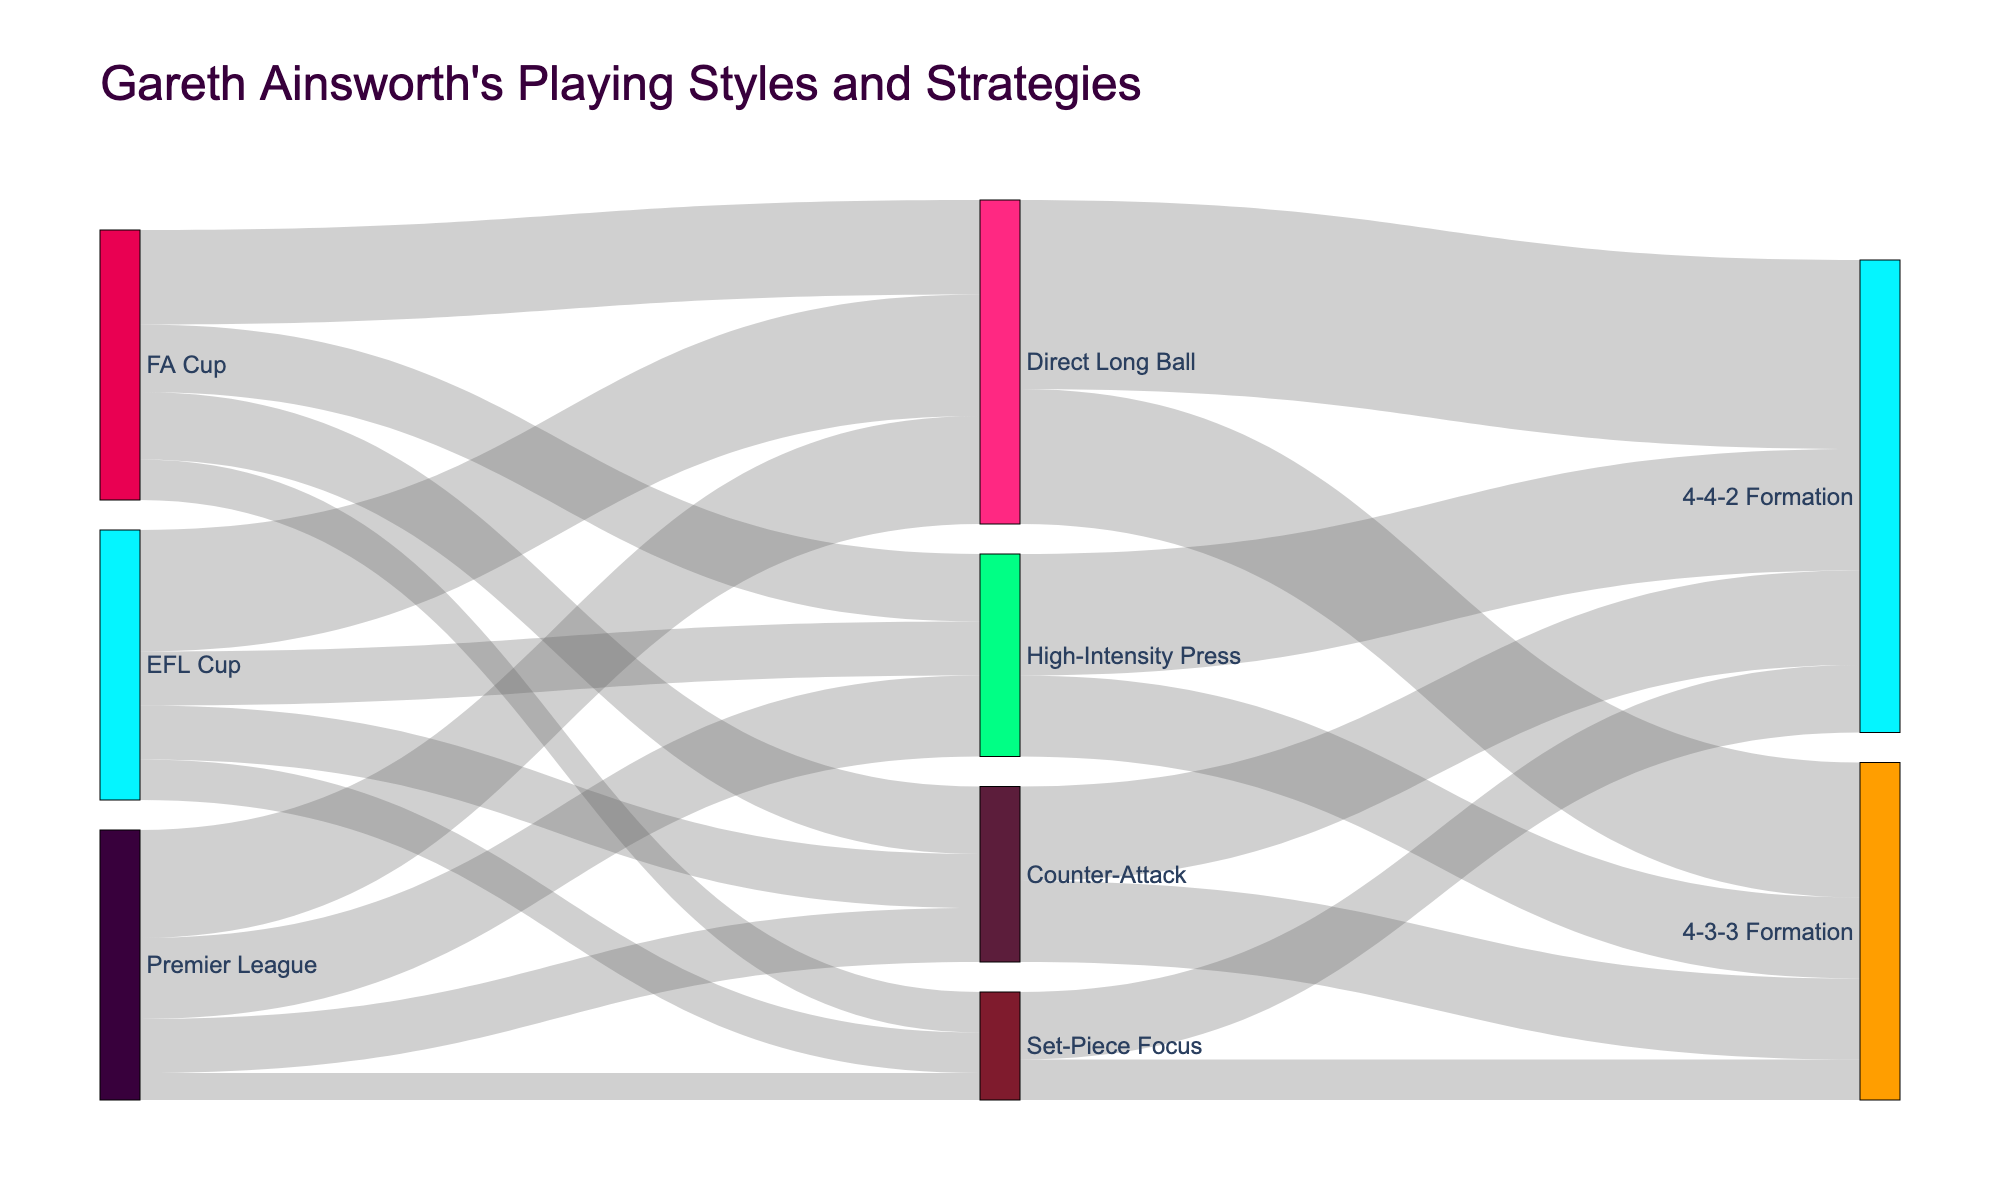what is the total value allocated to the High-Intensity Press strategy in all competitions? To find the total value for High-Intensity Press, sum the values for this strategy across Premier League, FA Cup, and EFL Cup. As given, Premier League: 30, FA Cup: 25, and EFL Cup: 20. Thus, 30 + 25 + 20 = 75
Answer: 75 Which competition employs the Direct Long Ball strategy the most? By comparing the values for Direct Long Ball across the different competitions, we see Premier League: 40, FA Cup: 35, and EFL Cup: 45. The EFL Cup has the highest value with 45
Answer: EFL Cup What formation is most frequently used with the Counter-Attack strategy? To determine the most frequently used formation, compare the values for formations linked to Counter-Attack. The values are 4-4-2: 35 and 4-3-3: 30. Thus, 4-4-2 Formation is used most frequently
Answer: 4-4-2 Formation How many playing styles are visualized in the diagram? The playing styles in the diagram are High-Intensity Press, Direct Long Ball, Counter-Attack, and Set-Piece Focus. Counting these, there are a total of 4
Answer: 4 What is the combined value of the Set-Piece Focus strategy across all competitions? Sum the values allocated to Set-Piece Focus in each competition: Premier League: 10, FA Cup: 15, and EFL Cup: 15. Thus, 10 + 15 + 15 = 40
Answer: 40 Between the Premier League and FA Cup, which competition uses the 4-3-3 formation in conjunction with High-Intensity Press more frequently? First, identify the values for 4-3-3 with High-Intensity Press in each competition. The data indicates that this specific link isn't broken down by competition within the diagram, implying direct totals aren't available; hence, unable to differentiate
Answer: Unable to differentiate Is the usage of 4-4-2 or 4-3-3 more balanced between the Direct Long Ball and Counter-Attack strategies? Compare the values for 4-4-2 with Direct Long Ball (70) and with Counter-Attack (35). Also, compare 4-3-3 with Direct Long Ball (50) and with Counter-Attack (30). 4-4-2 shows a difference of 70 - 35 = 35, and 4-3-3 shows a difference of 50-30 = 20, indicating 4-3-3 is more balanced
Answer: 4-3-3 is more balanced What is the majority playing style used in the Premier League? Compare the provided values: High-Intensity Press: 30, Direct Long Ball: 40, Counter-Attack: 20, and Set-Piece Focus: 10. The Premier League uses Direct Long Ball most with 40
Answer: Direct Long Ball 